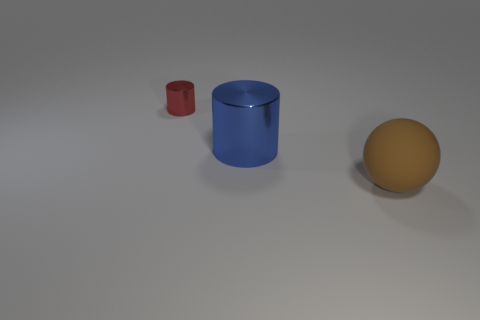Subtract all blue cylinders. How many cylinders are left? 1 Add 1 large blue things. How many objects exist? 4 Add 1 small blue shiny balls. How many small blue shiny balls exist? 1 Subtract 0 yellow cubes. How many objects are left? 3 Subtract all balls. How many objects are left? 2 Subtract all red cylinders. Subtract all yellow cubes. How many cylinders are left? 1 Subtract all yellow balls. How many blue cylinders are left? 1 Subtract all small red cylinders. Subtract all large metallic cylinders. How many objects are left? 1 Add 3 brown rubber spheres. How many brown rubber spheres are left? 4 